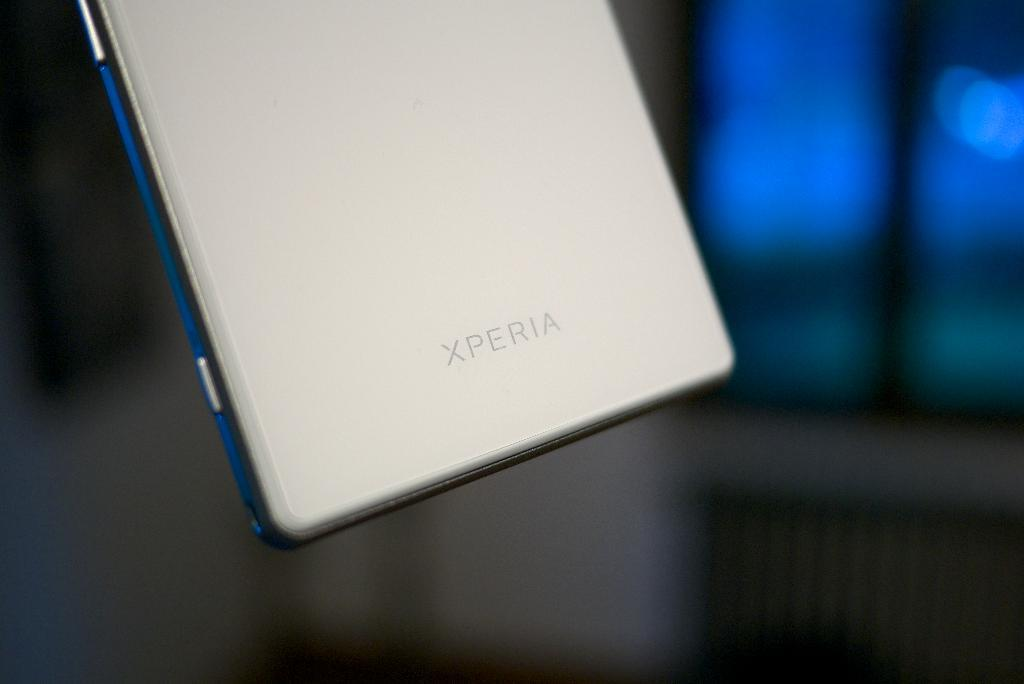<image>
Relay a brief, clear account of the picture shown. A close up of a phone which is made by Xperia. 